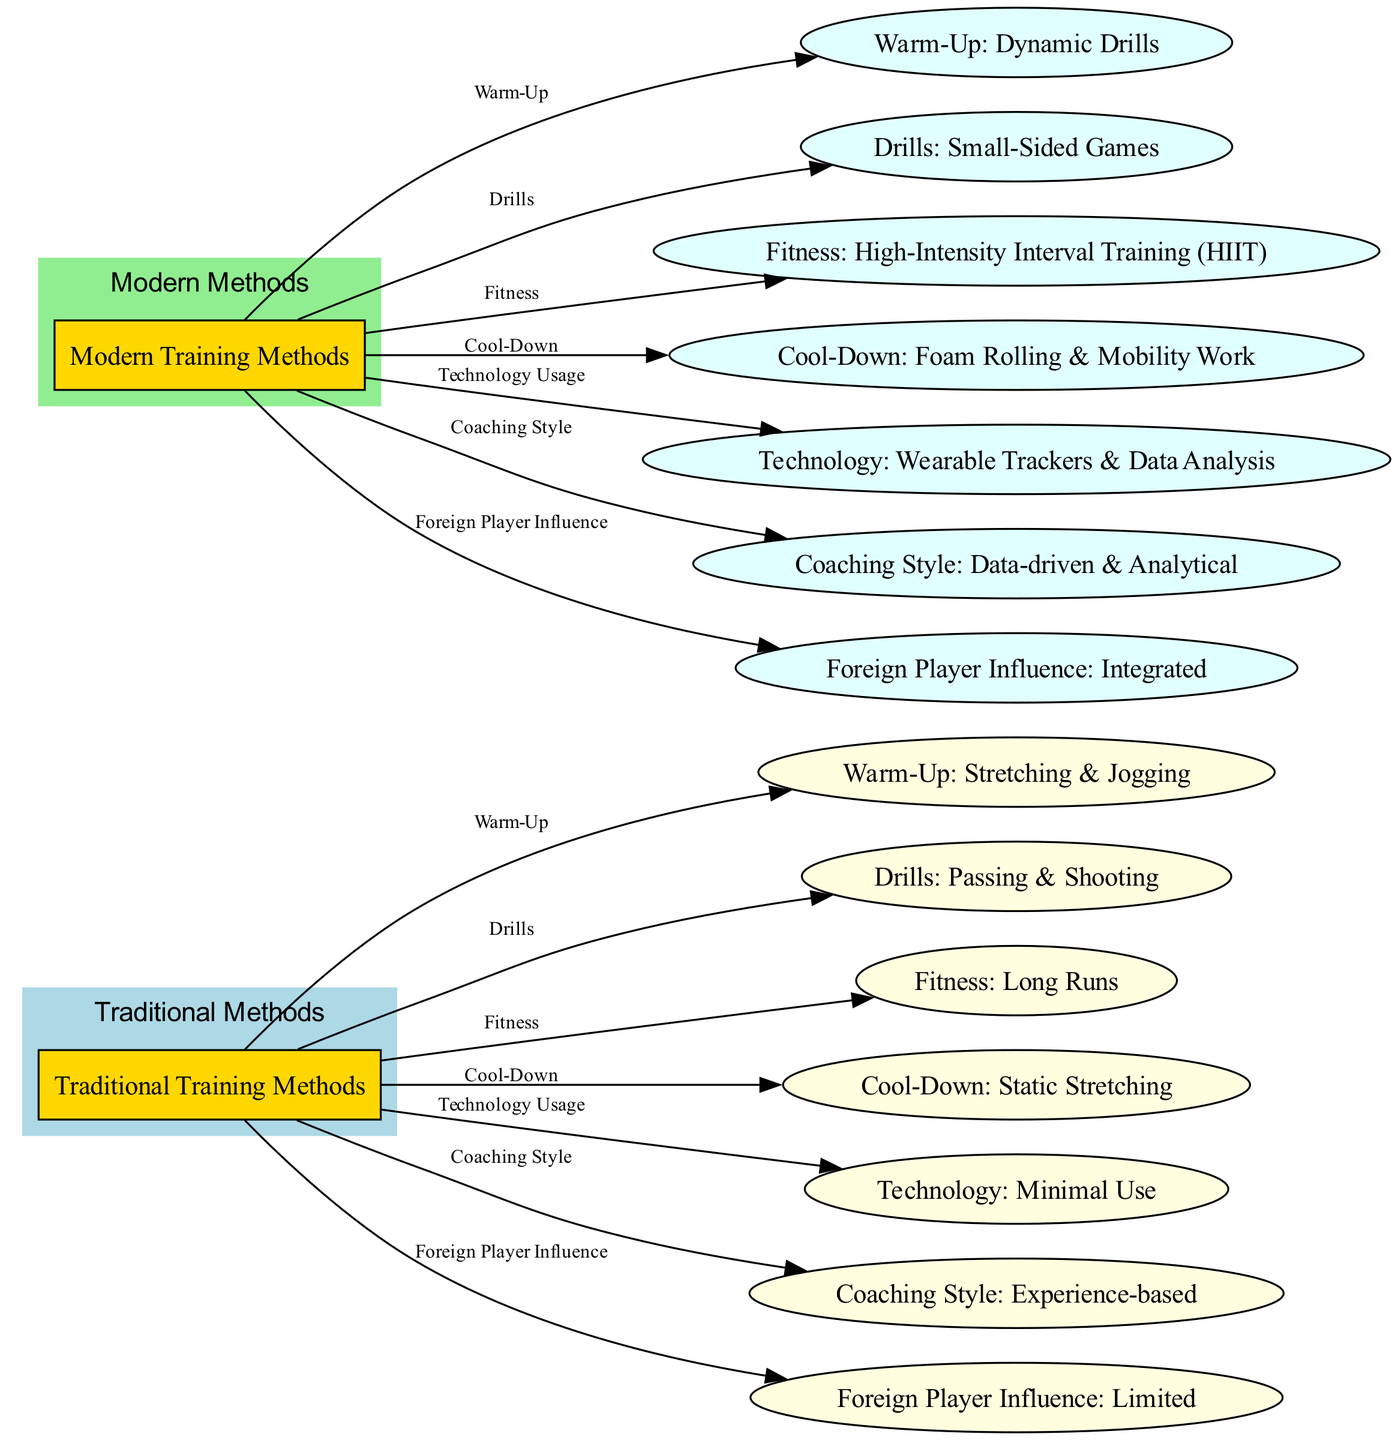What are the two main categories of training methods? The diagram highlights two primary categories: Traditional Training Methods and Modern Training Methods. These categories are clearly labeled in the main nodes of the diagram.
Answer: Traditional Training Methods, Modern Training Methods How many nodes represent traditional training methods? The traditional training methods are represented by six nodes in total, including the main category node and the subsequent warm-up, drills, fitness, cool-down, technology usage, coaching style, and foreign player influence nodes.
Answer: 6 What type of warm-up is associated with traditional methods? The diagram denotes that the warm-up linked with traditional methods involves Stretching & Jogging, which is displayed as a direct child node of Traditional Training Methods.
Answer: Stretching & Jogging Which modern fitness method is highlighted in the diagram? The fitness method emphasized for modern training methods is High-Intensity Interval Training (HIIT), identified as a child node of the Modern Training Methods category.
Answer: High-Intensity Interval Training (HIIT) What is the influence of foreign players in traditional training methods? According to the diagram, the foreign player influence in traditional training methods is categorized as Limited, indicating a lesser integration within the traditional framework.
Answer: Limited What are the two types of coaching styles presented in the diagram? The coaching styles illustrated include Experience-based for traditional methods and Data-driven & Analytical for modern methods, both showing contrasting approaches within the respective training categories.
Answer: Experience-based, Data-driven & Analytical Which technology usage is minimal according to traditional training methods? The diagram indicates that the technology usage in traditional training methods is labeled as Minimal Use, highlighting a lower reliance compared to modern methods, which utilize more advanced technology.
Answer: Minimal Use What relationship exists between traditional drills and passing? Traditional Training Methods shows a direct connection to drills specifically related to Passing & Shooting, evidencing the focus on fundamental skills in this approach.
Answer: Passing & Shooting How many edges represent the transition from traditional methods to specific training activities? The diagram has six edges linking traditional training methods to distinct activities, which encompass warm-up, drills, fitness, cool-down, technology usage, and coaching style, indicating these transitions clearly.
Answer: 6 